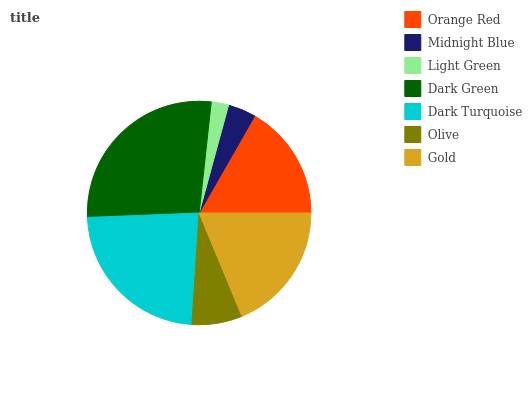Is Light Green the minimum?
Answer yes or no. Yes. Is Dark Green the maximum?
Answer yes or no. Yes. Is Midnight Blue the minimum?
Answer yes or no. No. Is Midnight Blue the maximum?
Answer yes or no. No. Is Orange Red greater than Midnight Blue?
Answer yes or no. Yes. Is Midnight Blue less than Orange Red?
Answer yes or no. Yes. Is Midnight Blue greater than Orange Red?
Answer yes or no. No. Is Orange Red less than Midnight Blue?
Answer yes or no. No. Is Orange Red the high median?
Answer yes or no. Yes. Is Orange Red the low median?
Answer yes or no. Yes. Is Gold the high median?
Answer yes or no. No. Is Light Green the low median?
Answer yes or no. No. 